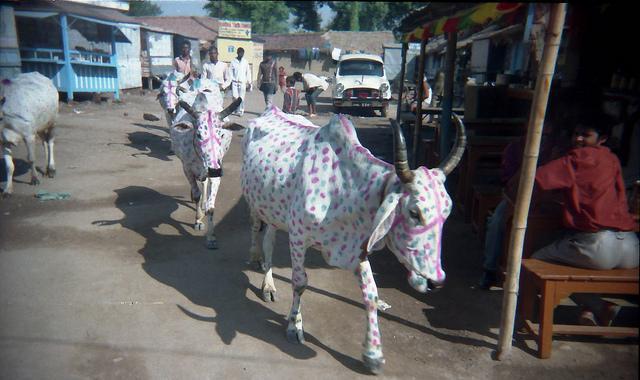How many cows can be seen?
Give a very brief answer. 3. How many people are there?
Give a very brief answer. 2. How many benches can you see?
Give a very brief answer. 1. How many trucks can you see?
Give a very brief answer. 1. 